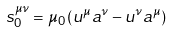<formula> <loc_0><loc_0><loc_500><loc_500>s _ { 0 } ^ { \mu \nu } = \mu _ { 0 } \left ( u ^ { \mu } a ^ { \nu } - u ^ { \nu } a ^ { \mu } \right )</formula> 